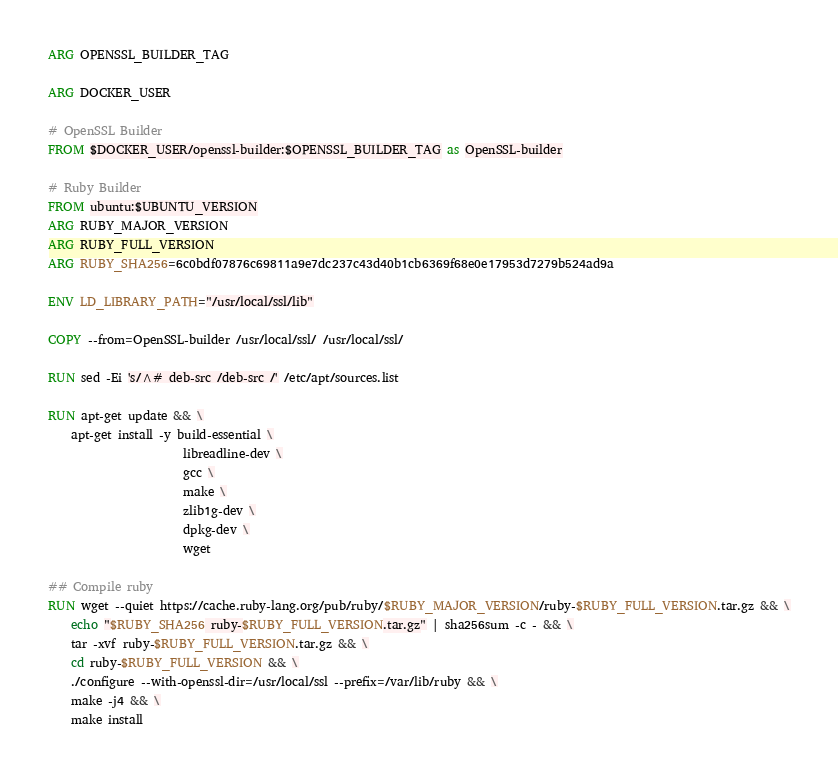Convert code to text. <code><loc_0><loc_0><loc_500><loc_500><_Dockerfile_>ARG OPENSSL_BUILDER_TAG

ARG DOCKER_USER

# OpenSSL Builder
FROM $DOCKER_USER/openssl-builder:$OPENSSL_BUILDER_TAG as OpenSSL-builder

# Ruby Builder
FROM ubuntu:$UBUNTU_VERSION
ARG RUBY_MAJOR_VERSION
ARG RUBY_FULL_VERSION
ARG RUBY_SHA256=6c0bdf07876c69811a9e7dc237c43d40b1cb6369f68e0e17953d7279b524ad9a

ENV LD_LIBRARY_PATH="/usr/local/ssl/lib"

COPY --from=OpenSSL-builder /usr/local/ssl/ /usr/local/ssl/

RUN sed -Ei 's/^# deb-src /deb-src /' /etc/apt/sources.list

RUN apt-get update && \
    apt-get install -y build-essential \
                       libreadline-dev \
                       gcc \
                       make \
                       zlib1g-dev \
                       dpkg-dev \
                       wget

## Compile ruby
RUN wget --quiet https://cache.ruby-lang.org/pub/ruby/$RUBY_MAJOR_VERSION/ruby-$RUBY_FULL_VERSION.tar.gz && \
    echo "$RUBY_SHA256 ruby-$RUBY_FULL_VERSION.tar.gz" | sha256sum -c - && \
    tar -xvf ruby-$RUBY_FULL_VERSION.tar.gz && \
    cd ruby-$RUBY_FULL_VERSION && \
    ./configure --with-openssl-dir=/usr/local/ssl --prefix=/var/lib/ruby && \
    make -j4 && \
    make install
</code> 